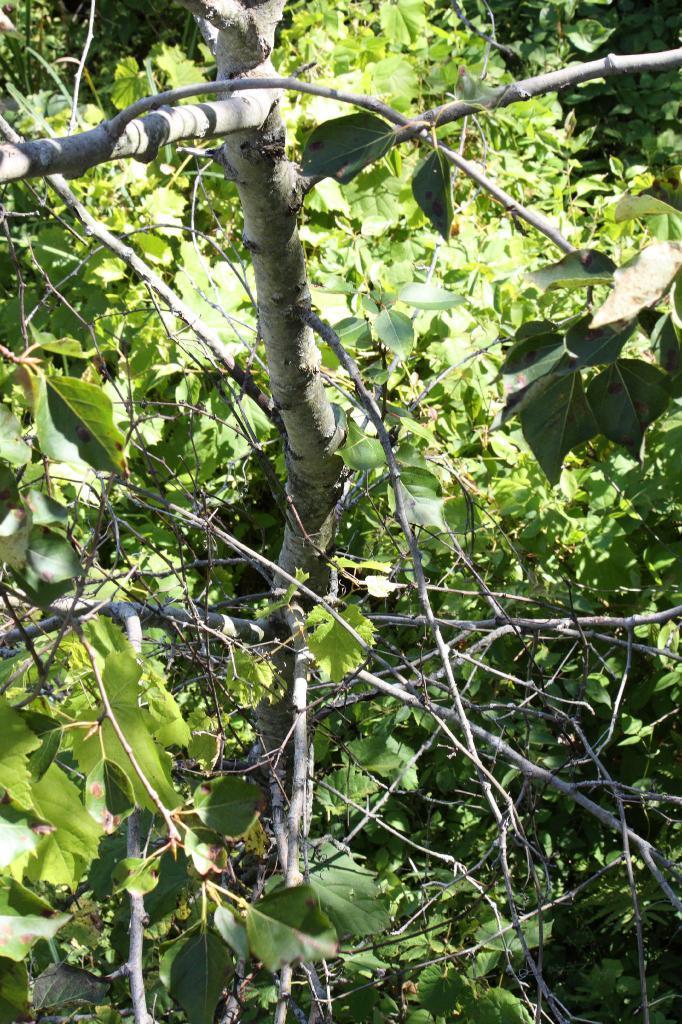Describe this image in one or two sentences. In this image there is a tree in the middle. At the bottom there are dry sticks and green leaves. 